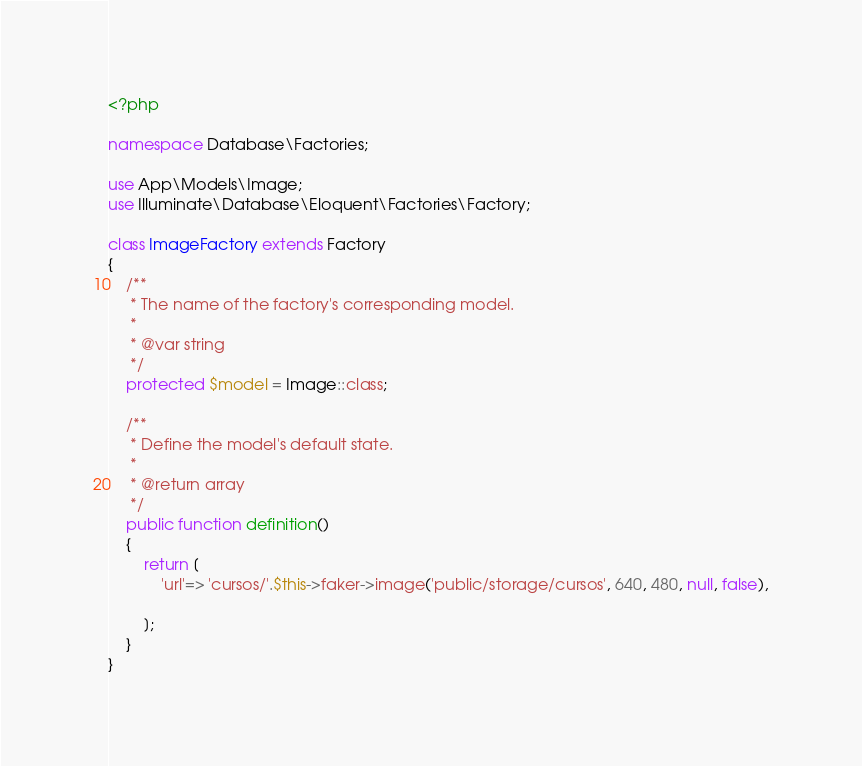<code> <loc_0><loc_0><loc_500><loc_500><_PHP_><?php

namespace Database\Factories;

use App\Models\Image;
use Illuminate\Database\Eloquent\Factories\Factory;

class ImageFactory extends Factory
{
    /**
     * The name of the factory's corresponding model.
     *
     * @var string
     */
    protected $model = Image::class;

    /**
     * Define the model's default state.
     *
     * @return array
     */
    public function definition()
    {
        return [
            'url'=> 'cursos/'.$this->faker->image('public/storage/cursos', 640, 480, null, false),
            
        ];
    }
}
</code> 